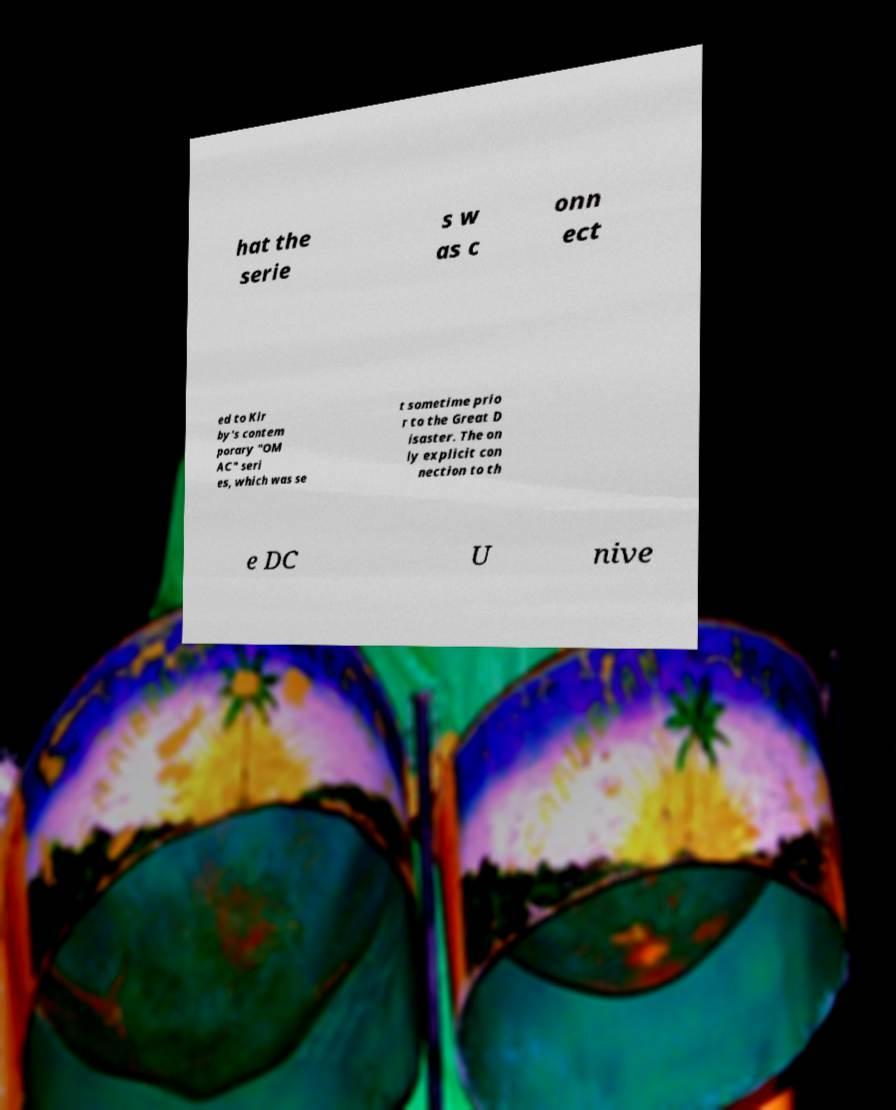Please identify and transcribe the text found in this image. hat the serie s w as c onn ect ed to Kir by's contem porary "OM AC" seri es, which was se t sometime prio r to the Great D isaster. The on ly explicit con nection to th e DC U nive 